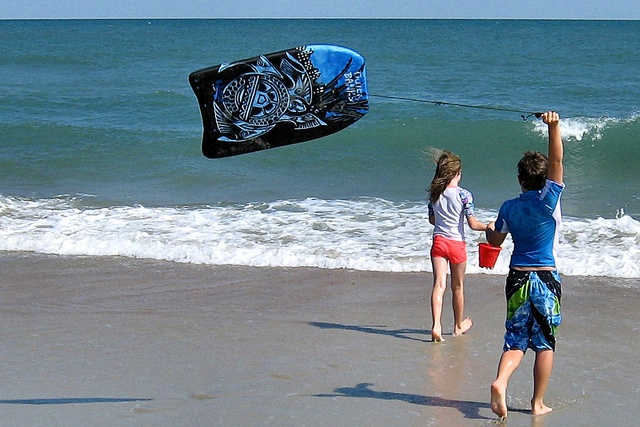Describe the objects in this image and their specific colors. I can see people in lightblue, navy, black, darkgray, and white tones, kite in lightblue, black, navy, and blue tones, and people in lightblue, lightgray, black, gray, and salmon tones in this image. 